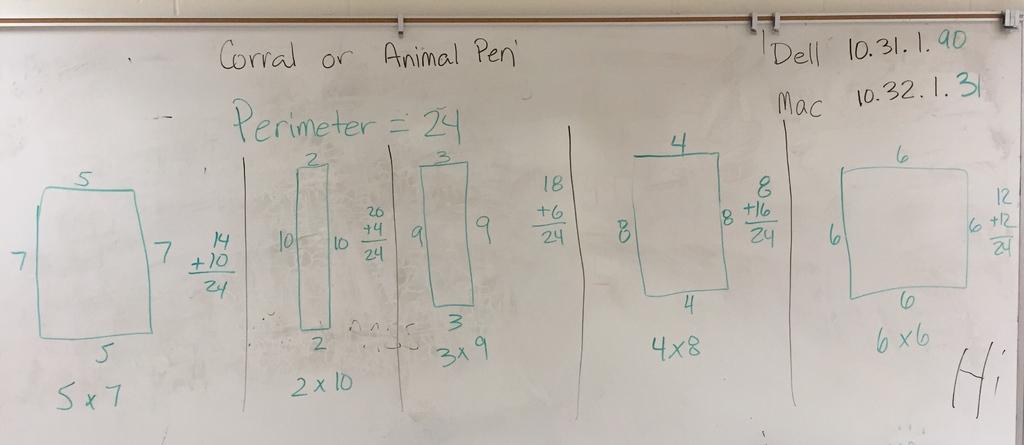Could you give a brief overview of what you see in this image? In this image we can see a board with some written words, numbers and boxes. 